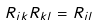<formula> <loc_0><loc_0><loc_500><loc_500>R _ { i k } R _ { k l } = R _ { i l }</formula> 